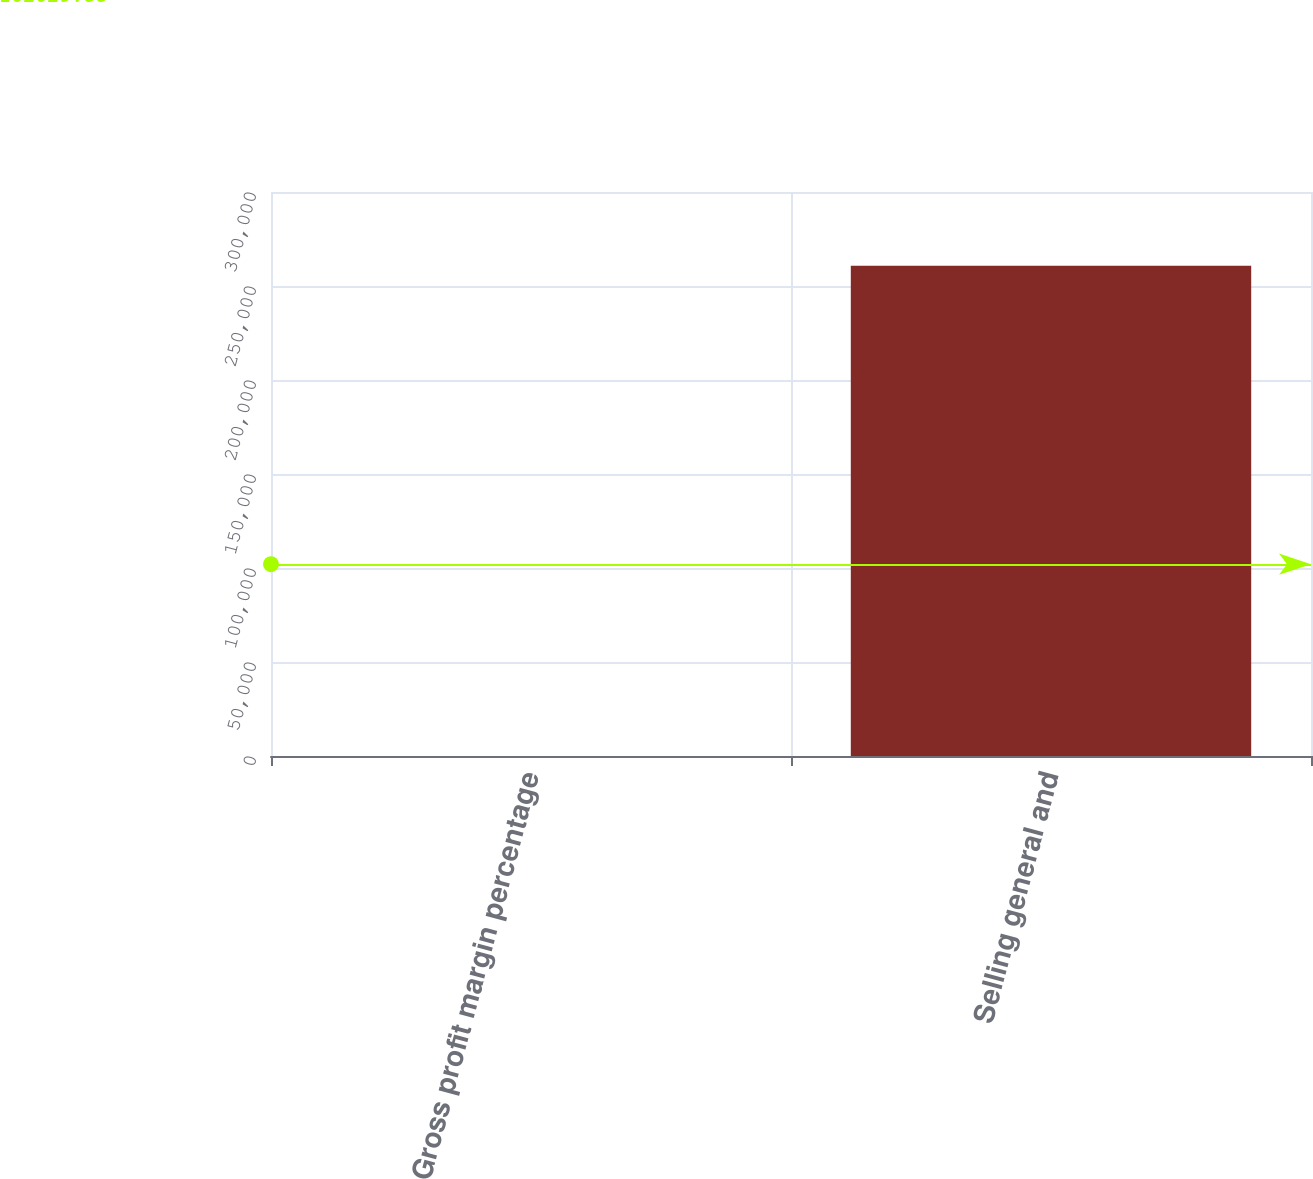<chart> <loc_0><loc_0><loc_500><loc_500><bar_chart><fcel>Gross profit margin percentage<fcel>Selling general and<nl><fcel>25.7<fcel>260795<nl></chart> 